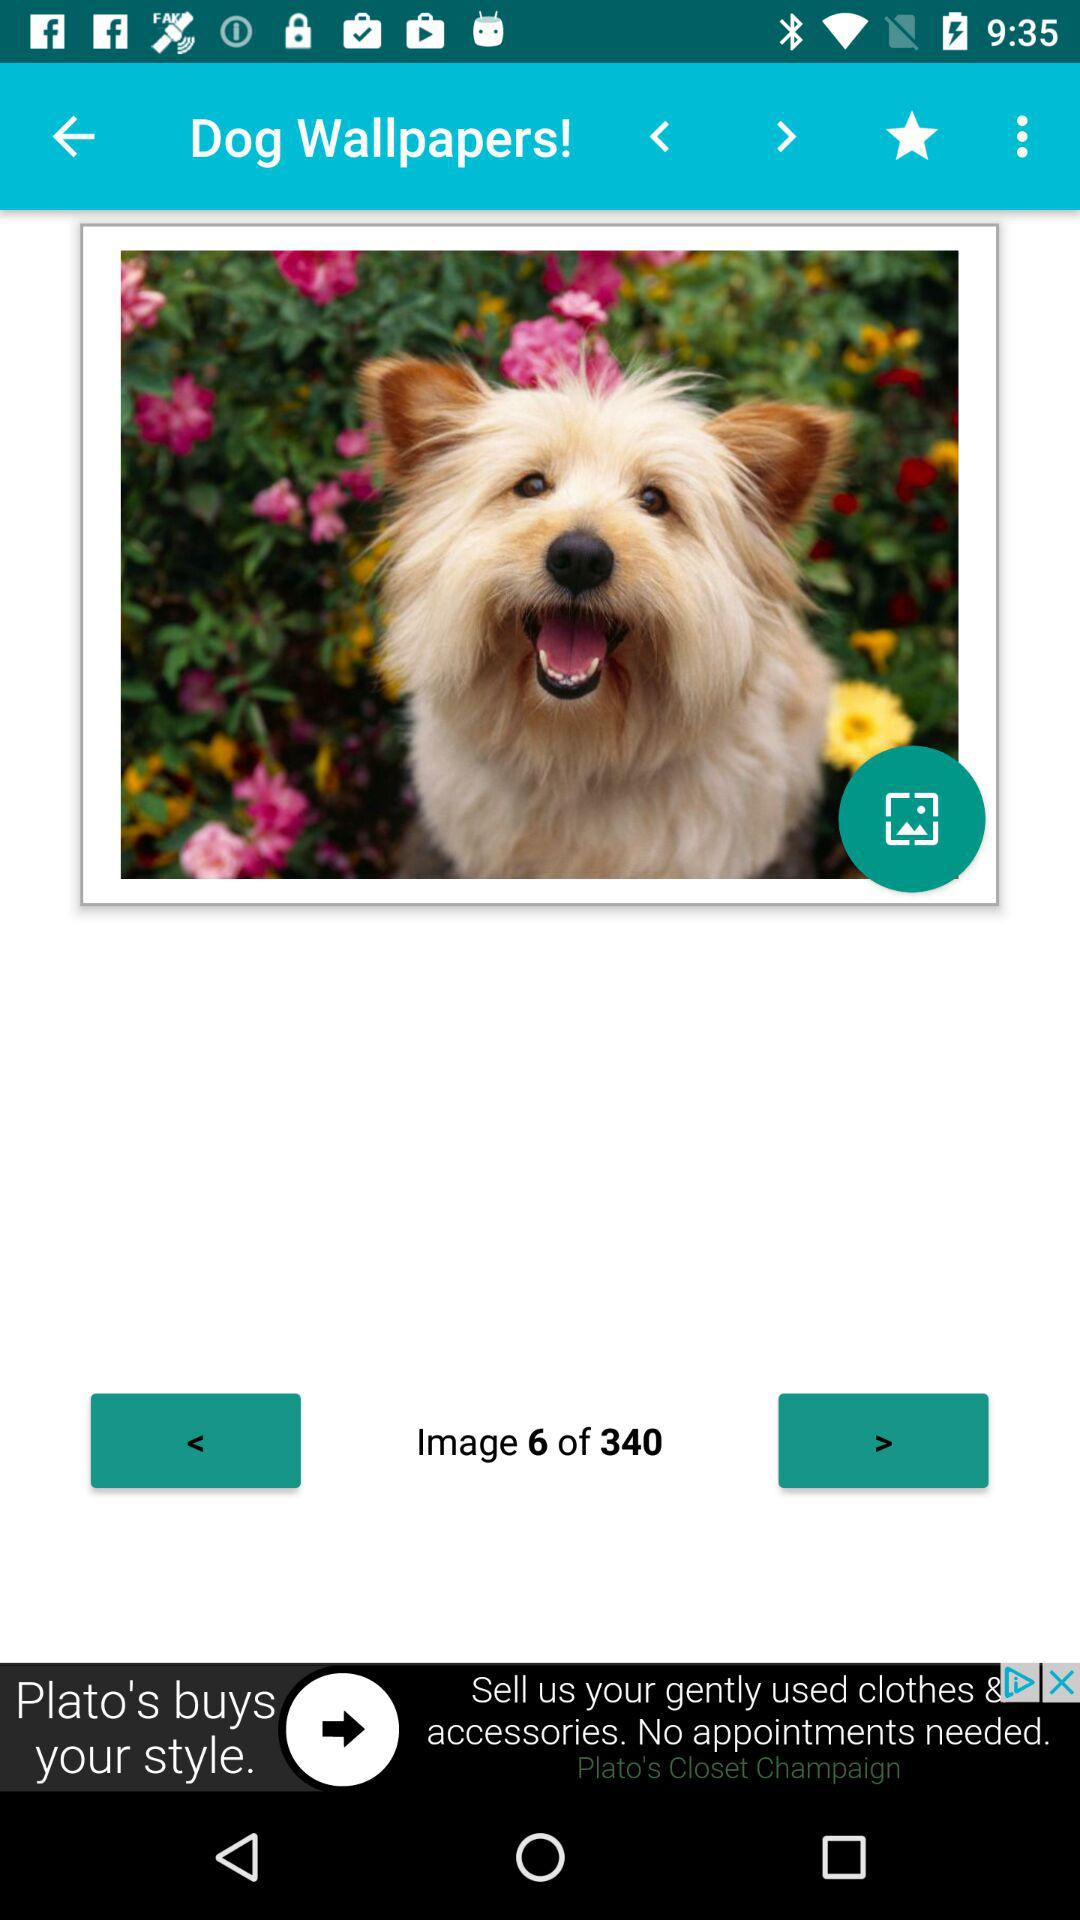How many wallpapers have dog images? The number of wallpapers that have dog images is 340. 